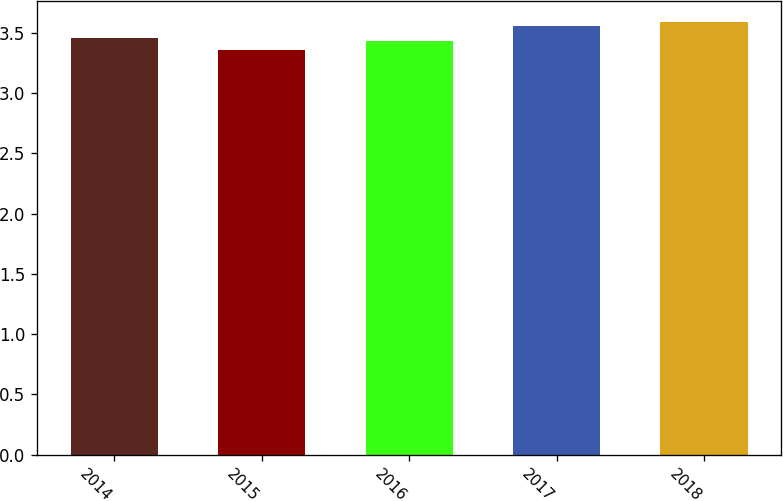Convert chart to OTSL. <chart><loc_0><loc_0><loc_500><loc_500><bar_chart><fcel>2014<fcel>2015<fcel>2016<fcel>2017<fcel>2018<nl><fcel>3.46<fcel>3.36<fcel>3.43<fcel>3.56<fcel>3.59<nl></chart> 